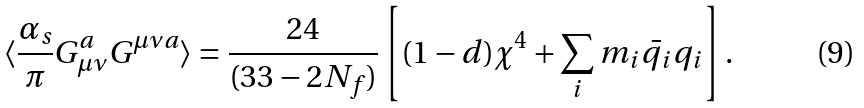Convert formula to latex. <formula><loc_0><loc_0><loc_500><loc_500>\langle \frac { \alpha _ { s } } { \pi } G _ { \mu \nu } ^ { a } G ^ { \mu \nu a } \rangle = \frac { 2 4 } { ( 3 3 - 2 N _ { f } ) } \left [ ( 1 - d ) \chi ^ { 4 } + \sum _ { i } m _ { i } \bar { q _ { i } } q _ { i } \right ] .</formula> 